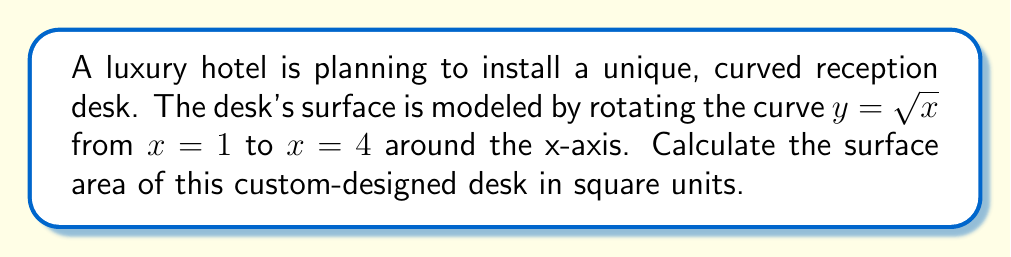Show me your answer to this math problem. To find the surface area of the rotated curve, we'll use the surface area of revolution formula:

$$S = 2\pi \int_a^b y \sqrt{1 + (\frac{dy}{dx})^2} dx$$

Where $y = \sqrt{x}$, $a = 1$, and $b = 4$.

Step 1: Find $\frac{dy}{dx}$
$$\frac{dy}{dx} = \frac{1}{2\sqrt{x}}$$

Step 2: Calculate $1 + (\frac{dy}{dx})^2$
$$1 + (\frac{dy}{dx})^2 = 1 + (\frac{1}{2\sqrt{x}})^2 = 1 + \frac{1}{4x} = \frac{4x+1}{4x}$$

Step 3: Substitute into the surface area formula
$$S = 2\pi \int_1^4 \sqrt{x} \sqrt{\frac{4x+1}{4x}} dx$$

Step 4: Simplify the integrand
$$S = 2\pi \int_1^4 \sqrt{x} \cdot \frac{\sqrt{4x+1}}{\sqrt{4x}} dx = 2\pi \int_1^4 \sqrt{\frac{4x+1}{4}} dx$$

Step 5: Substitute $u = 4x+1$, $du = 4dx$, and adjust the limits
$$S = 2\pi \int_5^{17} \frac{1}{4} \sqrt{u} \cdot \frac{1}{4} du = \frac{\pi}{8} \int_5^{17} \sqrt{u} du$$

Step 6: Integrate
$$S = \frac{\pi}{8} \cdot \frac{2}{3} u^{3/2} \Big|_5^{17} = \frac{\pi}{12} (17^{3/2} - 5^{3/2})$$

Step 7: Evaluate
$$S = \frac{\pi}{12} (70.1248 - 11.1803) \approx 15.4475\pi$$
Answer: $\frac{\pi}{12} (17^{3/2} - 5^{3/2}) \approx 15.4475\pi$ square units 